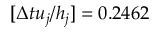Convert formula to latex. <formula><loc_0><loc_0><loc_500><loc_500>[ \Delta t u _ { j } / h _ { j } ] = 0 . 2 4 6 2</formula> 